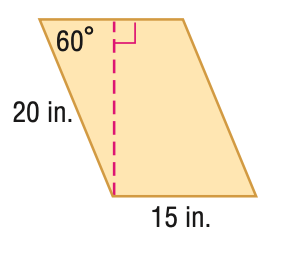Question: Find the area of the parallelogram. Round to the nearest tenth if necessary.
Choices:
A. 86.6
B. 129.9
C. 150.0
D. 259.8
Answer with the letter. Answer: D 